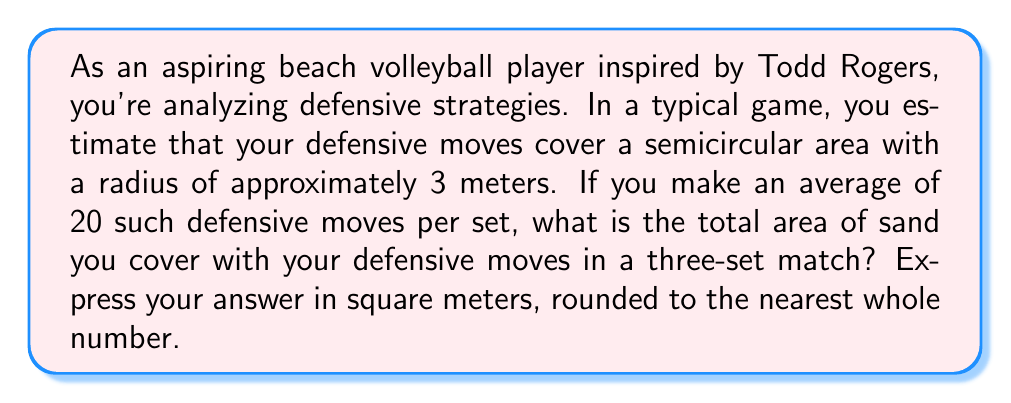Can you solve this math problem? Let's break this down step-by-step:

1) First, we need to calculate the area of a single defensive move. The area covered is a semicircle with a radius of 3 meters.

2) The formula for the area of a circle is $A = \pi r^2$, where $r$ is the radius.

3) For a semicircle, we use half of this: $A = \frac{1}{2} \pi r^2$

4) Substituting our radius of 3 meters:

   $A = \frac{1}{2} \pi (3)^2 = \frac{1}{2} \pi (9) = \frac{9\pi}{2}$ square meters

5) Now, we need to calculate how many defensive moves are made in total:
   - There are 20 moves per set
   - The match has 3 sets
   - Total moves = $20 \times 3 = 60$ moves

6) The total area covered is the area of one move multiplied by the number of moves:

   Total Area = $60 \times \frac{9\pi}{2} = 270\pi$ square meters

7) Using $\pi \approx 3.14159$, we get:

   Total Area $\approx 270 \times 3.14159 \approx 848.23$ square meters

8) Rounding to the nearest whole number:

   Total Area $\approx 848$ square meters
Answer: $848$ square meters 